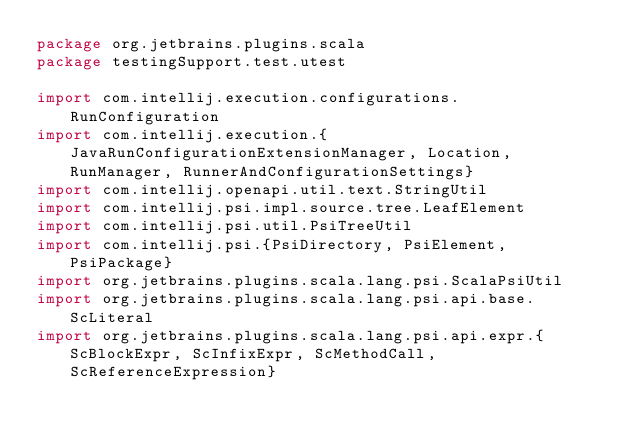<code> <loc_0><loc_0><loc_500><loc_500><_Scala_>package org.jetbrains.plugins.scala
package testingSupport.test.utest

import com.intellij.execution.configurations.RunConfiguration
import com.intellij.execution.{JavaRunConfigurationExtensionManager, Location, RunManager, RunnerAndConfigurationSettings}
import com.intellij.openapi.util.text.StringUtil
import com.intellij.psi.impl.source.tree.LeafElement
import com.intellij.psi.util.PsiTreeUtil
import com.intellij.psi.{PsiDirectory, PsiElement, PsiPackage}
import org.jetbrains.plugins.scala.lang.psi.ScalaPsiUtil
import org.jetbrains.plugins.scala.lang.psi.api.base.ScLiteral
import org.jetbrains.plugins.scala.lang.psi.api.expr.{ScBlockExpr, ScInfixExpr, ScMethodCall, ScReferenceExpression}</code> 